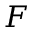<formula> <loc_0><loc_0><loc_500><loc_500>F</formula> 